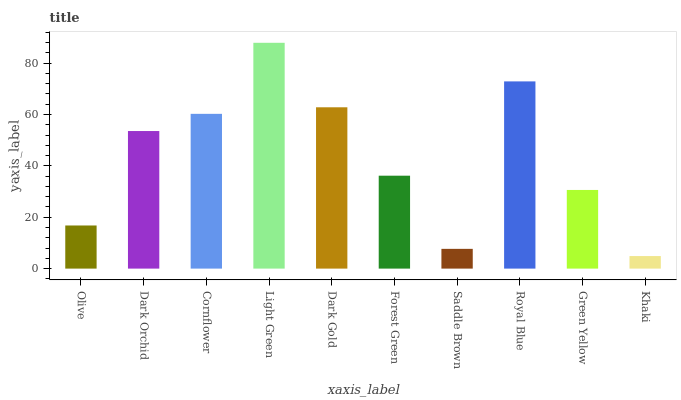Is Khaki the minimum?
Answer yes or no. Yes. Is Light Green the maximum?
Answer yes or no. Yes. Is Dark Orchid the minimum?
Answer yes or no. No. Is Dark Orchid the maximum?
Answer yes or no. No. Is Dark Orchid greater than Olive?
Answer yes or no. Yes. Is Olive less than Dark Orchid?
Answer yes or no. Yes. Is Olive greater than Dark Orchid?
Answer yes or no. No. Is Dark Orchid less than Olive?
Answer yes or no. No. Is Dark Orchid the high median?
Answer yes or no. Yes. Is Forest Green the low median?
Answer yes or no. Yes. Is Saddle Brown the high median?
Answer yes or no. No. Is Dark Orchid the low median?
Answer yes or no. No. 